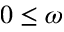<formula> <loc_0><loc_0><loc_500><loc_500>0 \leq \omega</formula> 